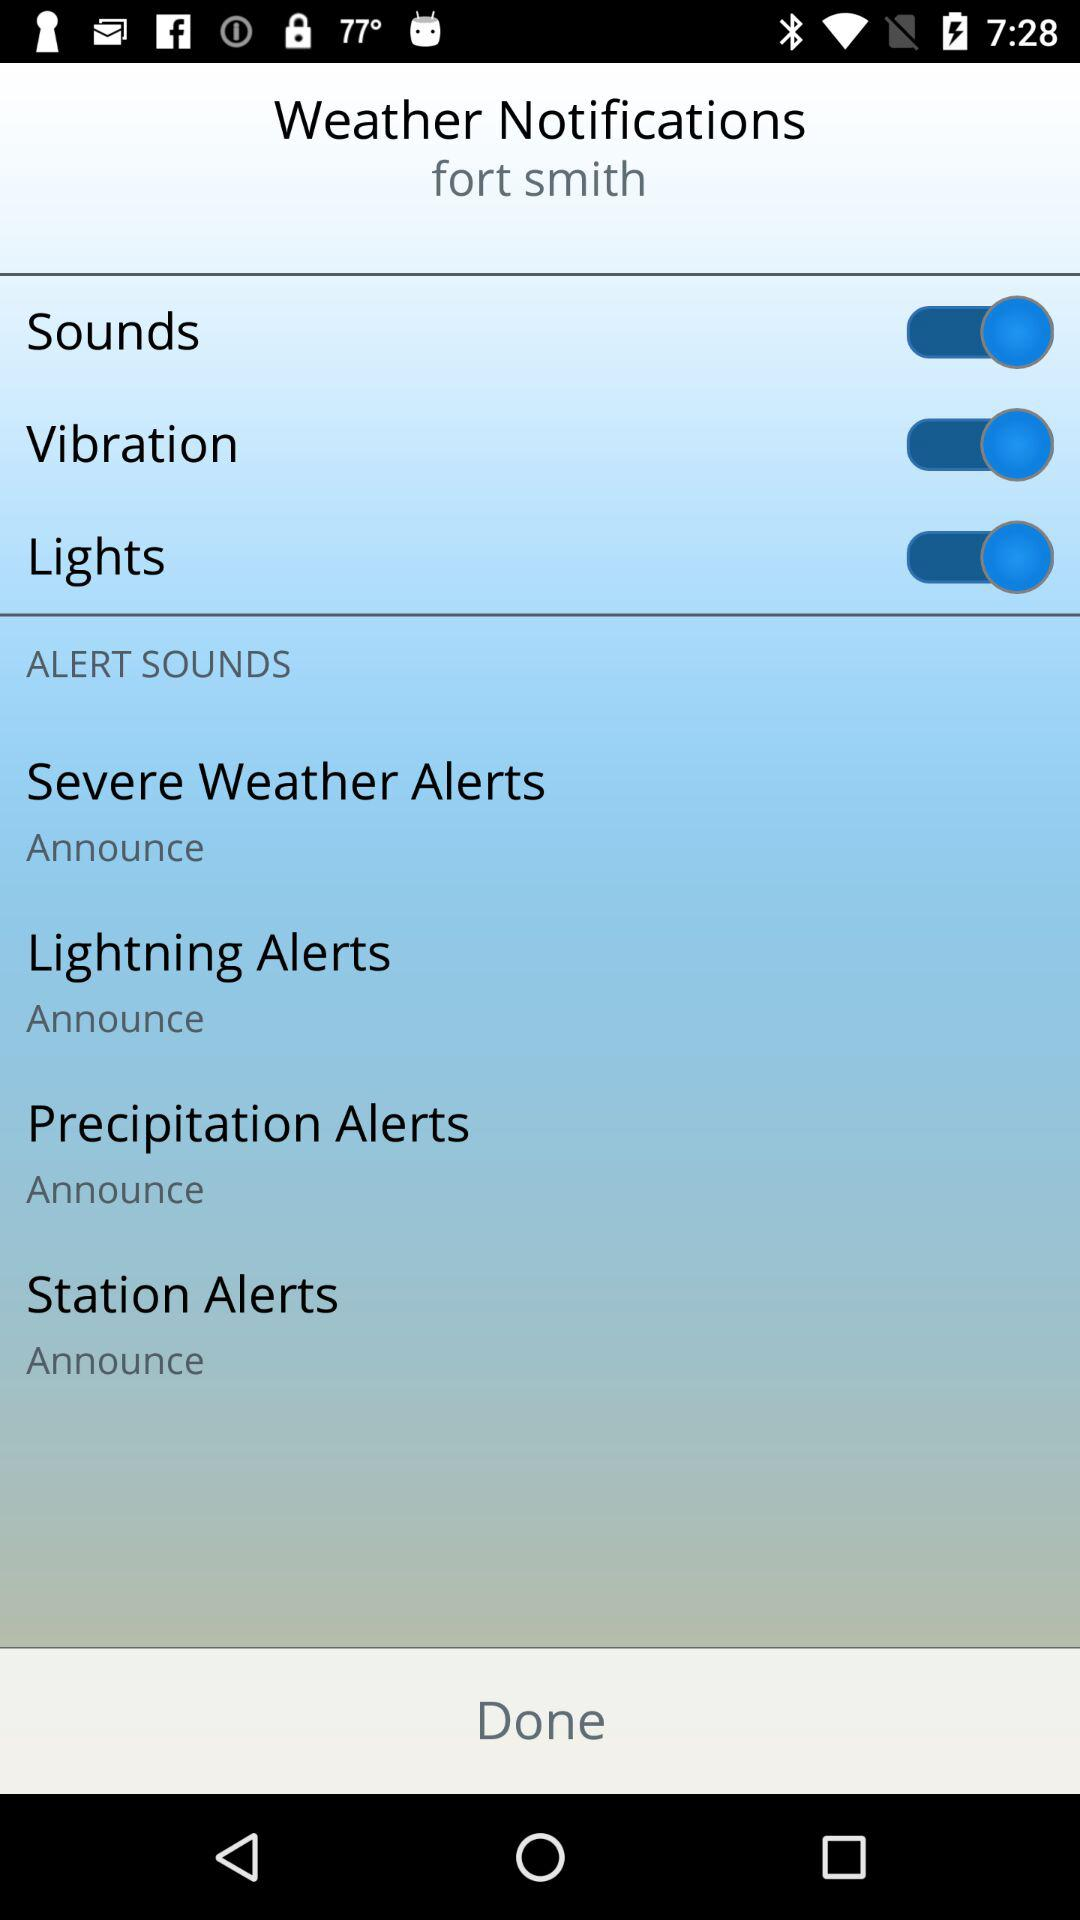What is the status of "Sounds"? The status is "on". 